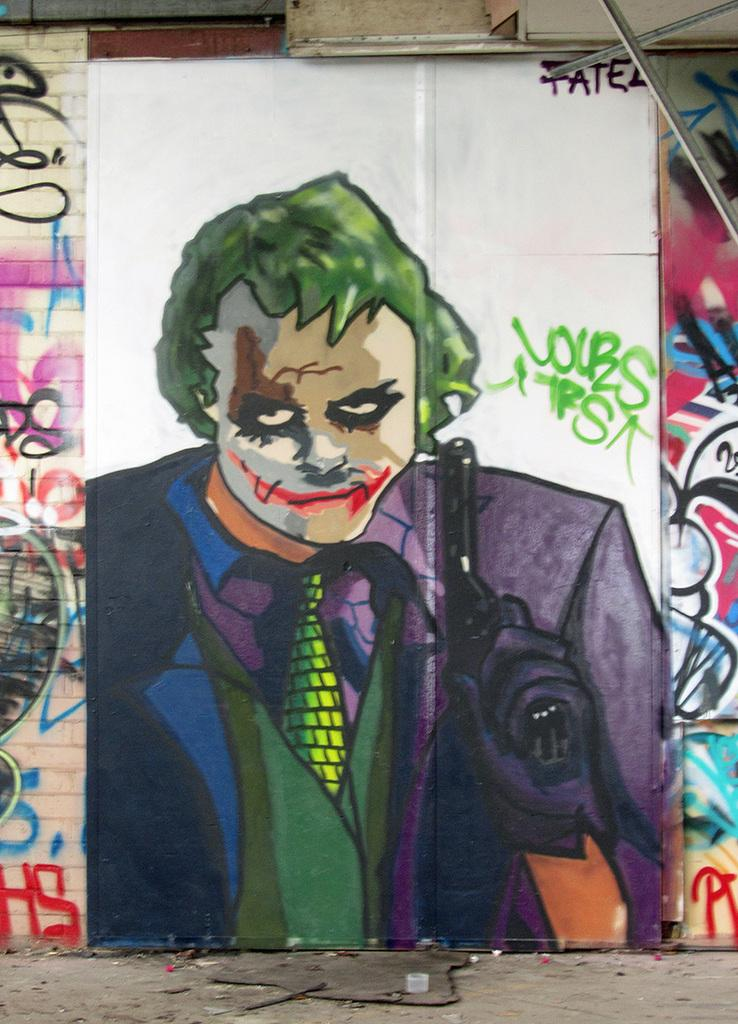What type of artwork is on the wall in the image? There is a painting of a person on the wall in the image. What other type of artwork can be seen in the image? There is graffiti visible in the image. What type of cabbage is growing in the image? There is no cabbage present in the image. How many people are walking in the rainstorm in the image? There is no rainstorm present in the image. What type of chalk is being used to draw the graffiti in the image? The facts provided do not mention the type of chalk used for the graffiti, nor is there any chalk visible in the image. 